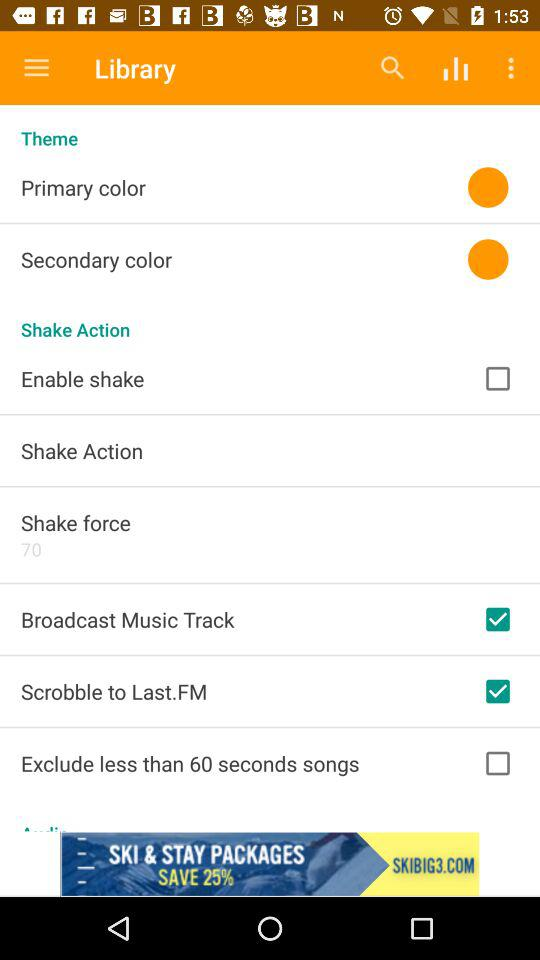What is the status of enable shake? The status is off. 